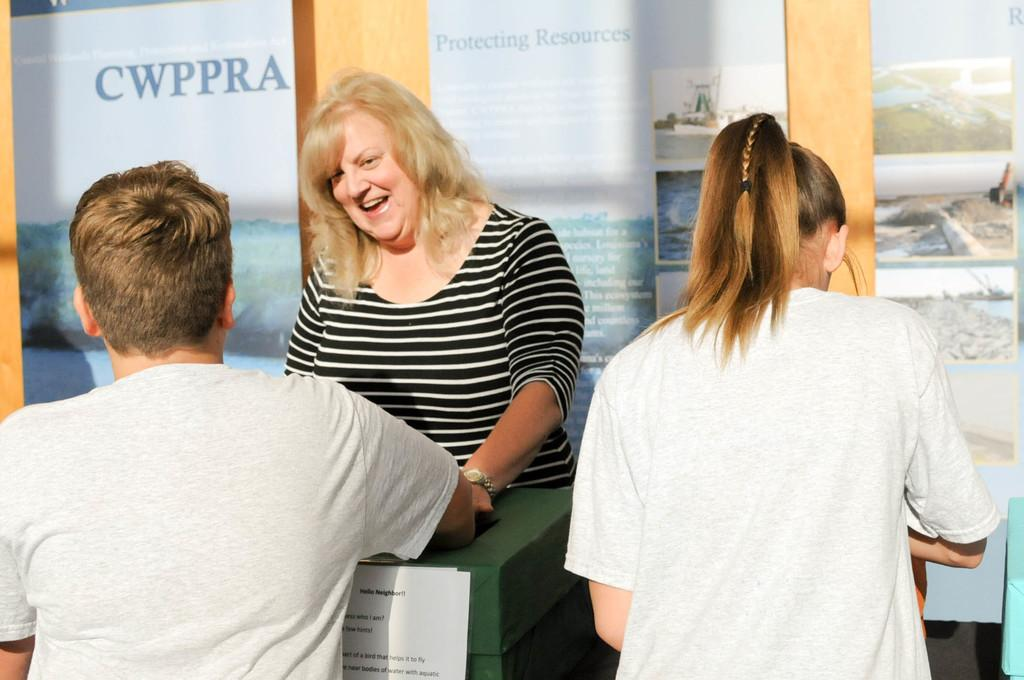How many people are present in the image? There are three people in the image. What is the woman wearing in the image? The woman is wearing a watch. What is the facial expression of the woman in the image? The woman is smiling. What can be seen on the paper in the image? The facts provided do not specify any details about the paper, so we cannot answer this question definitively. What type of objects are present in the image? The facts provided do not specify the type of objects, so we cannot answer this question definitively. What is visible on the wall in the background of the image? There are posters on the wall in the background. What type of plantation can be seen in the image? There is no plantation present in the image. How many stomachs can be seen in the image? There are no stomachs visible in the image. 